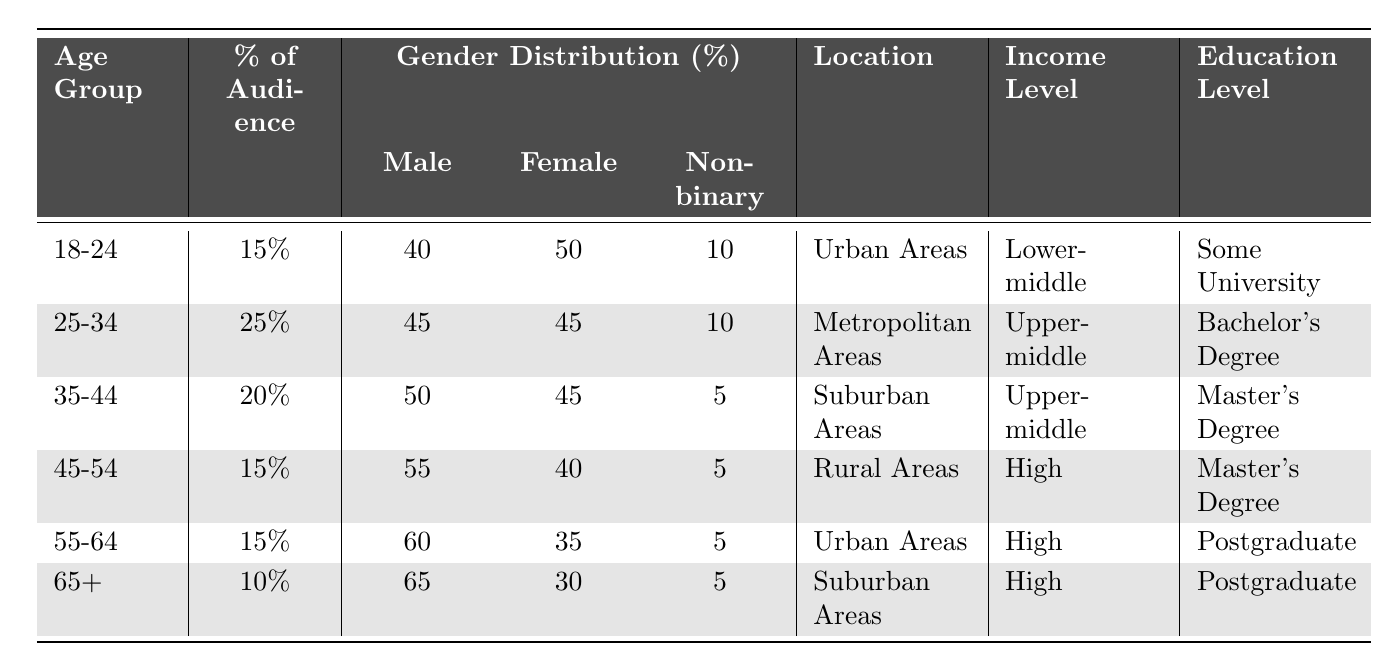What percentage of the audience is in the age group 25-34? The table shows that the percentage of the audience in the 25-34 age group is clearly marked as 25%.
Answer: 25% Which age group has the lowest percentage of audience? By examining the percentages listed, the age group 65+ has the lowest percentage at 10%.
Answer: 65+ What is the income level for the audience aged 45-54? The table indicates that the income level for the 45-54 age group is classified as High.
Answer: High Is the majority gender for the 18-24 age group male or female? The gender distribution for the 18-24 age group lists 50% female and 40% male, indicating that female is the majority.
Answer: Female What is the average percentage of the audience across all age groups? Adding the percentages (15 + 25 + 20 + 15 + 15 + 10 = 100) gives a total of 100%, and since there are 6 age groups, the average is 100% / 6 = 16.67%.
Answer: 16.67% What is the education level of the majority in the 55-64 age group? The table states that the education level of the 55-64 age group is Postgraduate, which aligns with the categories listed.
Answer: Postgraduate How does the gender distribution of the 35-44 age group compare to the 45-54 age group? For the 35-44 age group, the distribution is 50% male and 45% female. For the 45-54 age group, it is 55% male and 40% female. This indicates the 45-54 age group has a higher male percentage compared to the 35-44 age group.
Answer: 45-54 has more males In which locations are the youngest and oldest age groups primarily based? The youngest (18-24) are in Urban Areas, while the oldest (65+) are in Suburban Areas, indicating distinct geographical preferences.
Answer: Urban and Suburban If you combine the percentages for 25-34 and 35-44 age groups, what is the total audience percentage? Adding these percentages (25% + 20% = 45%) provides the total percentage for these two combined age groups in the audience.
Answer: 45% 